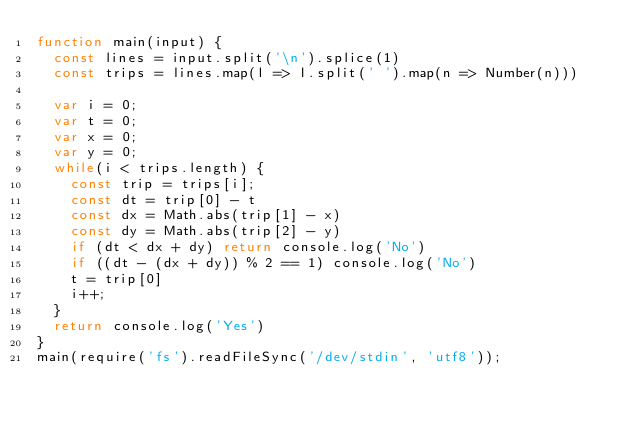<code> <loc_0><loc_0><loc_500><loc_500><_JavaScript_>function main(input) {
  const lines = input.split('\n').splice(1)
  const trips = lines.map(l => l.split(' ').map(n => Number(n)))
  
  var i = 0;
  var t = 0;
  var x = 0;
  var y = 0;
  while(i < trips.length) {
    const trip = trips[i]; 
    const dt = trip[0] - t
    const dx = Math.abs(trip[1] - x)
    const dy = Math.abs(trip[2] - y)
    if (dt < dx + dy) return console.log('No')
    if ((dt - (dx + dy)) % 2 == 1) console.log('No')
    t = trip[0]
    i++;
  }
  return console.log('Yes')
}
main(require('fs').readFileSync('/dev/stdin', 'utf8'));</code> 